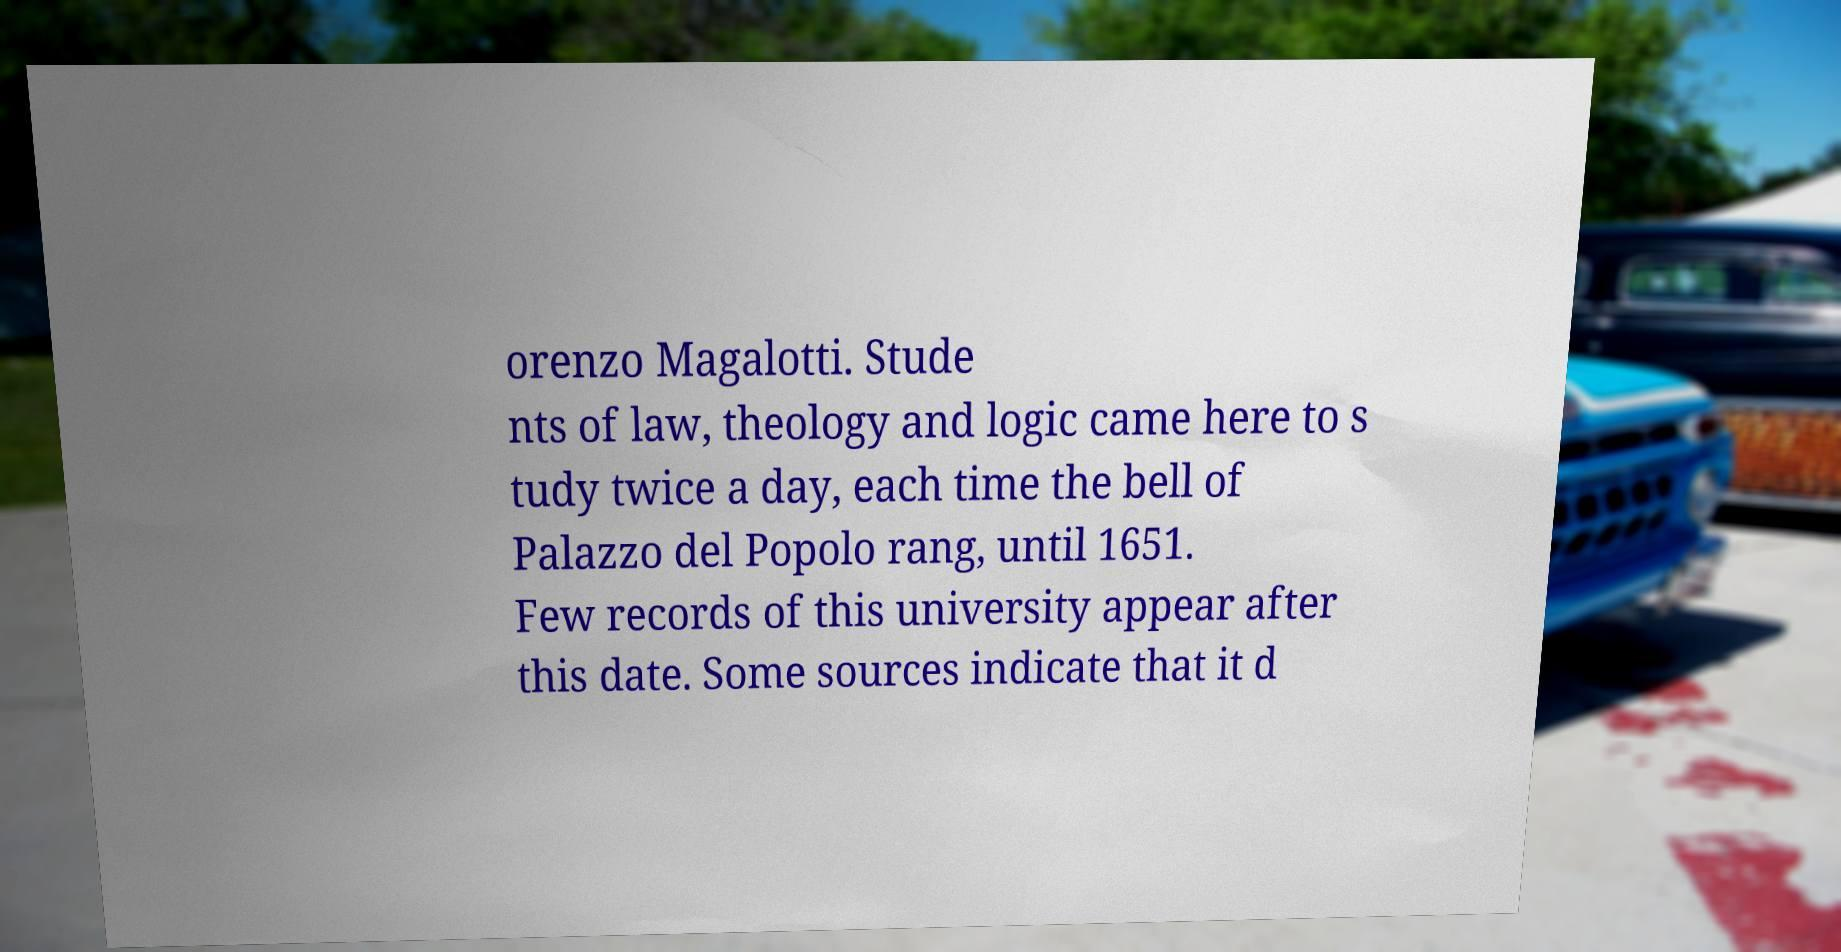Can you read and provide the text displayed in the image?This photo seems to have some interesting text. Can you extract and type it out for me? orenzo Magalotti. Stude nts of law, theology and logic came here to s tudy twice a day, each time the bell of Palazzo del Popolo rang, until 1651. Few records of this university appear after this date. Some sources indicate that it d 